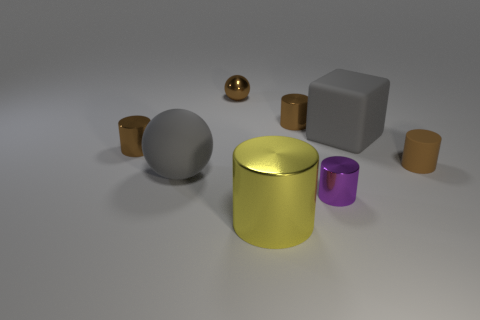Subtract all brown cylinders. How many were subtracted if there are1brown cylinders left? 2 Subtract all yellow balls. How many brown cylinders are left? 3 Subtract all purple cylinders. How many cylinders are left? 4 Subtract all yellow shiny cylinders. How many cylinders are left? 4 Subtract all blue cylinders. Subtract all gray balls. How many cylinders are left? 5 Add 2 small cyan matte cubes. How many objects exist? 10 Subtract all balls. How many objects are left? 6 Add 8 large gray cubes. How many large gray cubes exist? 9 Subtract 1 purple cylinders. How many objects are left? 7 Subtract all large yellow metal blocks. Subtract all large balls. How many objects are left? 7 